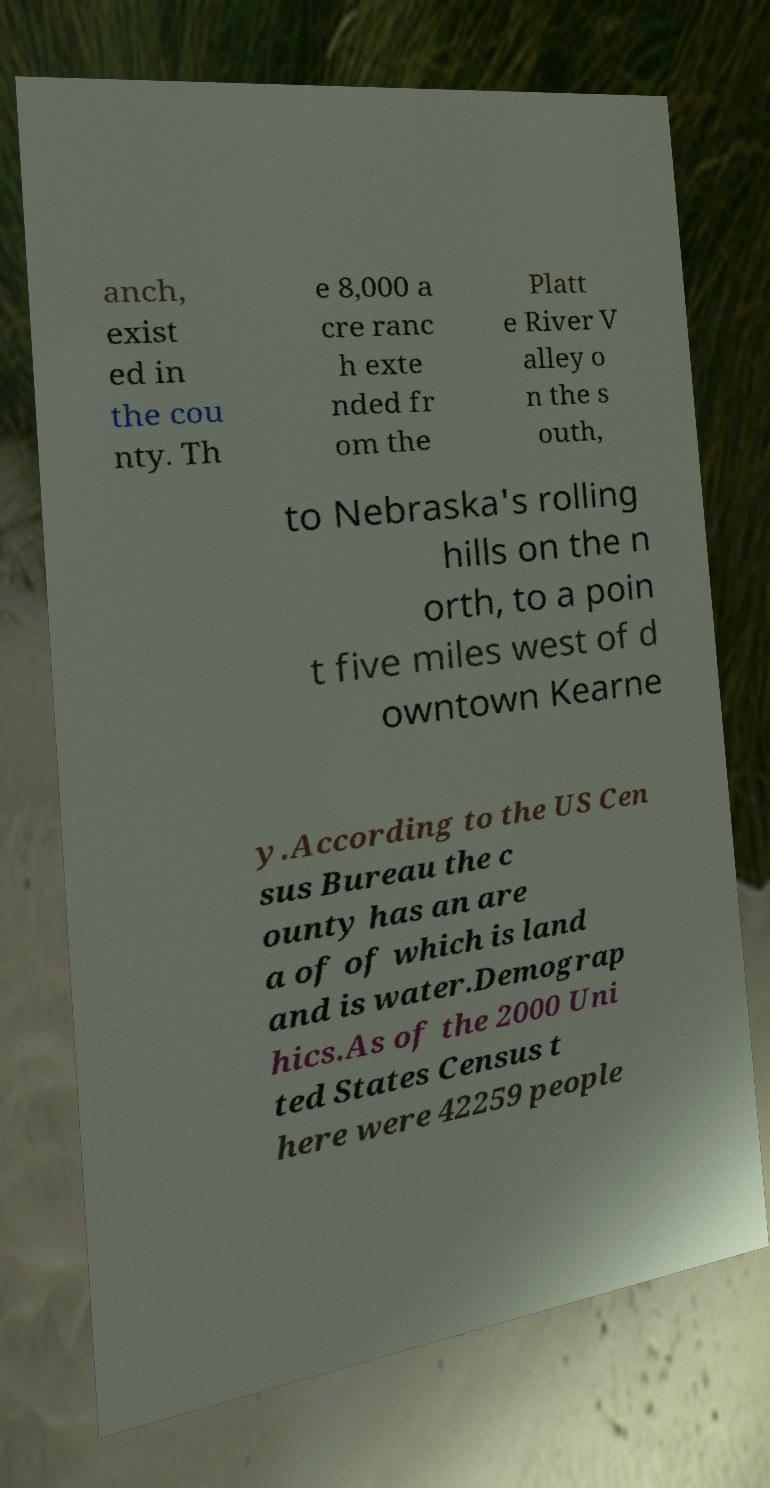Please read and relay the text visible in this image. What does it say? anch, exist ed in the cou nty. Th e 8,000 a cre ranc h exte nded fr om the Platt e River V alley o n the s outh, to Nebraska's rolling hills on the n orth, to a poin t five miles west of d owntown Kearne y.According to the US Cen sus Bureau the c ounty has an are a of of which is land and is water.Demograp hics.As of the 2000 Uni ted States Census t here were 42259 people 